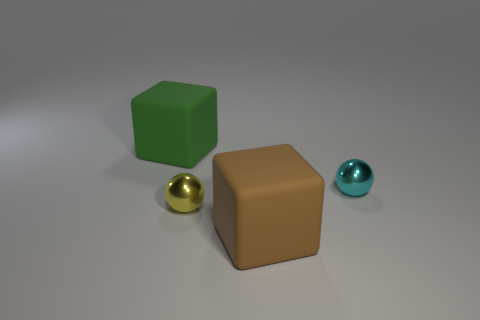There is a object that is both on the left side of the large brown block and in front of the cyan shiny thing; what is its shape?
Provide a short and direct response. Sphere. There is a small object that is the same material as the tiny yellow sphere; what is its color?
Your response must be concise. Cyan. There is a shiny thing that is behind the sphere left of the metallic ball that is behind the yellow thing; what is its shape?
Ensure brevity in your answer.  Sphere. The yellow ball is what size?
Provide a succinct answer. Small. What shape is the other thing that is the same material as the brown thing?
Keep it short and to the point. Cube. Is the number of large brown rubber things that are behind the large brown rubber block less than the number of cylinders?
Your response must be concise. No. There is a metal sphere that is right of the small yellow shiny thing; what color is it?
Your answer should be compact. Cyan. Is there another green object that has the same shape as the big green thing?
Your answer should be compact. No. What number of other tiny shiny objects have the same shape as the small cyan shiny object?
Provide a short and direct response. 1. Is the number of large matte blocks less than the number of things?
Offer a very short reply. Yes. 